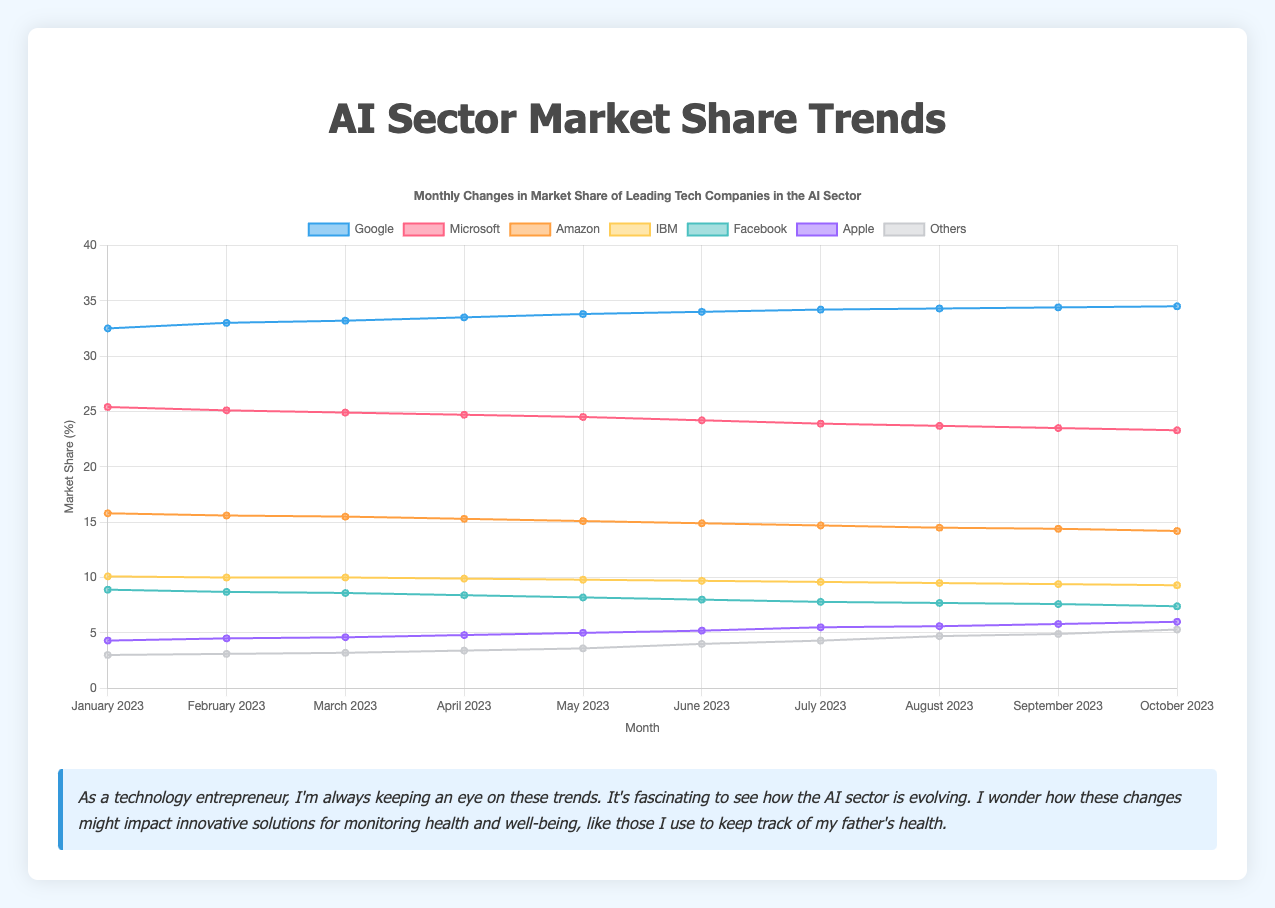How has Google's market share changed from January 2023 to October 2023? To find the change in Google's market share from January 2023 to October 2023, look at Google's market share for both months and subtract January's value from October's value. Google's market share in January was 32.5%, and it increased to 34.5% in October. Thus, the change is 34.5 - 32.5 = 2.0%.
Answer: 2.0% Which company showed the greatest increase in market share from January to October 2023? By examining the market shares for each company in January and October and calculating the difference, we can determine that Google increased from 32.5% to 34.5% (2.0% increase), Microsoft decreased from 25.4% to 23.3% (2.1% decrease), Amazon decreased from 15.8% to 14.2% (1.6% decrease), IBM decreased from 10.1% to 9.3% (0.8% decrease), Facebook decreased from 8.9% to 7.4% (1.5% decrease), Apple increased from 4.3% to 6.0% (1.7% increase), and Others increased from 3.0% to 5.3% (2.3% increase). Thus, 'Others' showed the greatest increase of 2.3%.
Answer: Others How did Microsoft's market share trend over the months? Microsoft's market share started at 25.4% in January and gradually decreased each month, ending at 23.3% in October. The trend shows a consistent decline in market share over the period.
Answer: Declining Which companies had a market share lower than 10% in October 2023? Looking at the October 2023 data, the companies with market shares lower than 10% are Amazon (14.2%), IBM (9.3%), Facebook (7.4%), Apple (6.0%), and Others (5.3%).
Answer: Amazon, IBM, Facebook, Apple, Others What was the combined market share of Facebook and IBM in April 2023? To find the combined market share of Facebook and IBM in April 2023, add their individual shares: Facebook has 8.4% and IBM has 9.9%. Therefore, the combined share is 8.4 + 9.9 = 18.3%.
Answer: 18.3% Are there any companies that consistently increased their market share each month from January to October 2023? By analyzing the data, the companies that consistently increased their market share each month are Google, Apple, and Others. Google increased from 32.5% to 34.5%, Apple increased from 4.3% to 6.0%, and Others increased from 3.0% to 5.3%.
Answer: Google, Apple, Others What visual attributes describe the trend of Facebook’s market share on the chart? Visually, Facebook's market share shows a declining trend. This can be seen as a line that generally slopes downward from January (8.9%) to October (7.4%). The color associated with the Facebook line on the chart can help distinguish it from other companies.
Answer: Downward sloping line What is the average monthly market share for Amazon across the 10 months? To calculate the average, you sum Amazon's market shares for each month and then divide by the number of months. The market shares for Amazon from January to October are: 15.8, 15.6, 15.5, 15.3, 15.1, 14.9, 14.7, 14.5, 14.4, and 14.2. Adding these gives a total of 149.0, and dividing by 10 months gives an average of 14.9%.
Answer: 14.9% Which company had the smallest fluctuation in market share between January and October 2023? To determine the smallest fluctuation, calculate the difference between the highest and lowest market share values for each company. Google fluctuated from 32.5% to 34.5% (2.0% range), Microsoft from 25.4% to 23.3% (2.1% range), Amazon from 15.8% to 14.2% (1.6% range), IBM from 10.1% to 9.3% (0.8% range), Facebook from 8.9% to 7.4% (1.5% range), Apple from 4.3% to 6.0% (1.7% range), and Others from 3.0% to 5.3% (2.3% range). IBM had the smallest fluctuation of 0.8%.
Answer: IBM 